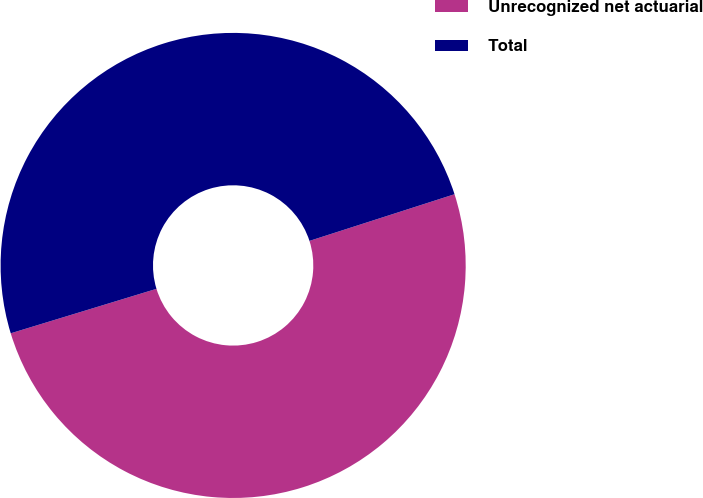<chart> <loc_0><loc_0><loc_500><loc_500><pie_chart><fcel>Unrecognized net actuarial<fcel>Total<nl><fcel>50.24%<fcel>49.76%<nl></chart> 